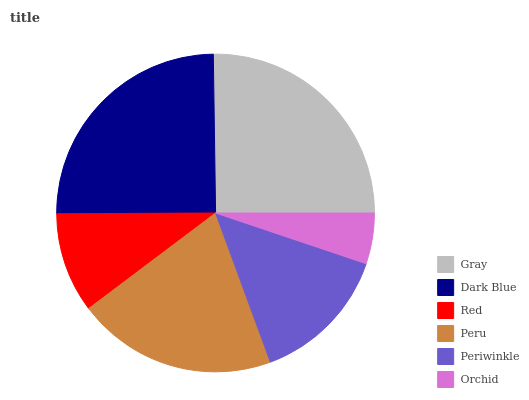Is Orchid the minimum?
Answer yes or no. Yes. Is Gray the maximum?
Answer yes or no. Yes. Is Dark Blue the minimum?
Answer yes or no. No. Is Dark Blue the maximum?
Answer yes or no. No. Is Gray greater than Dark Blue?
Answer yes or no. Yes. Is Dark Blue less than Gray?
Answer yes or no. Yes. Is Dark Blue greater than Gray?
Answer yes or no. No. Is Gray less than Dark Blue?
Answer yes or no. No. Is Peru the high median?
Answer yes or no. Yes. Is Periwinkle the low median?
Answer yes or no. Yes. Is Gray the high median?
Answer yes or no. No. Is Orchid the low median?
Answer yes or no. No. 